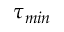Convert formula to latex. <formula><loc_0><loc_0><loc_500><loc_500>\tau _ { \min }</formula> 